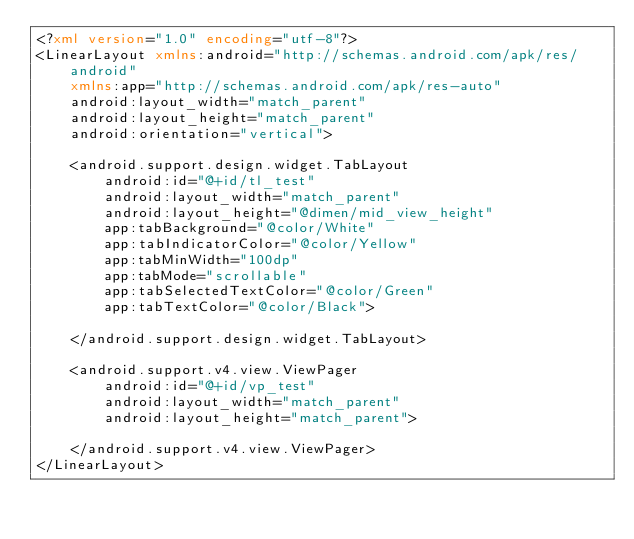Convert code to text. <code><loc_0><loc_0><loc_500><loc_500><_XML_><?xml version="1.0" encoding="utf-8"?>
<LinearLayout xmlns:android="http://schemas.android.com/apk/res/android"
    xmlns:app="http://schemas.android.com/apk/res-auto"
    android:layout_width="match_parent"
    android:layout_height="match_parent"
    android:orientation="vertical">

    <android.support.design.widget.TabLayout
        android:id="@+id/tl_test"
        android:layout_width="match_parent"
        android:layout_height="@dimen/mid_view_height"
        app:tabBackground="@color/White"
        app:tabIndicatorColor="@color/Yellow"
        app:tabMinWidth="100dp"
        app:tabMode="scrollable"
        app:tabSelectedTextColor="@color/Green"
        app:tabTextColor="@color/Black">

    </android.support.design.widget.TabLayout>

    <android.support.v4.view.ViewPager
        android:id="@+id/vp_test"
        android:layout_width="match_parent"
        android:layout_height="match_parent">

    </android.support.v4.view.ViewPager>
</LinearLayout></code> 